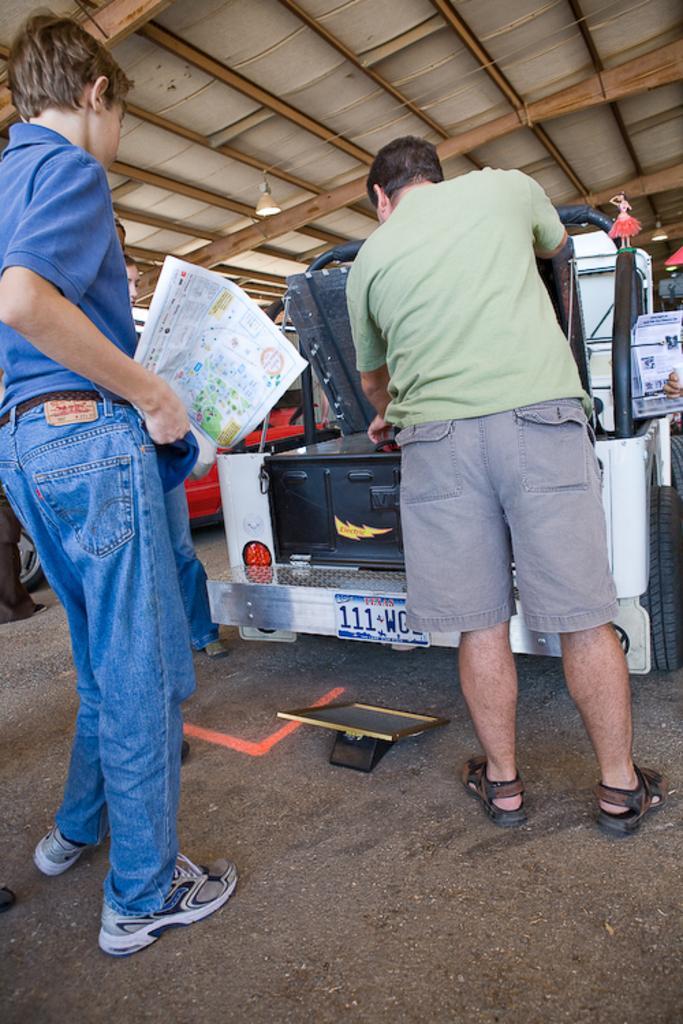How would you summarize this image in a sentence or two? In this image I can see there are two people standing in the foreground and I can see there is a vehicle and other people are standing near the vehicle. 